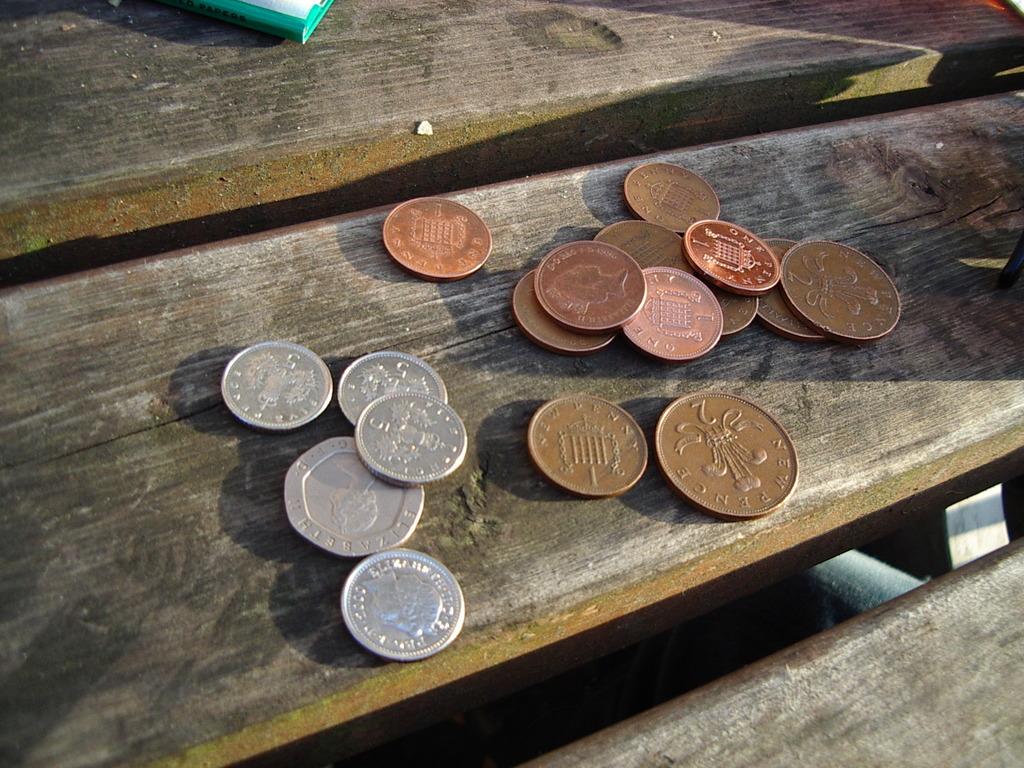How many change are there in silver coins?
Offer a terse response. 5. 